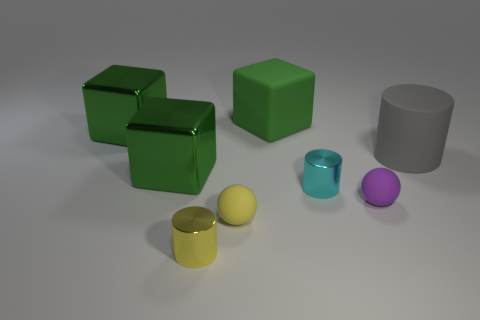What is the size of the metal object that is on the right side of the metallic thing in front of the small cyan metallic thing on the right side of the large green matte thing?
Your answer should be compact. Small. Are there any other things that have the same shape as the small yellow matte object?
Provide a succinct answer. Yes. There is a ball that is to the left of the purple ball to the right of the cyan metal cylinder; how big is it?
Offer a terse response. Small. How many large things are either matte objects or yellow things?
Ensure brevity in your answer.  2. Is the number of big green objects less than the number of blue objects?
Your answer should be very brief. No. Is there any other thing that is the same size as the yellow matte sphere?
Make the answer very short. Yes. Do the big cylinder and the matte block have the same color?
Ensure brevity in your answer.  No. Is the number of matte cylinders greater than the number of blocks?
Make the answer very short. No. How many other objects are there of the same color as the large rubber cube?
Make the answer very short. 2. There is a tiny metallic cylinder that is on the left side of the cyan shiny thing; how many tiny metal cylinders are behind it?
Ensure brevity in your answer.  1. 